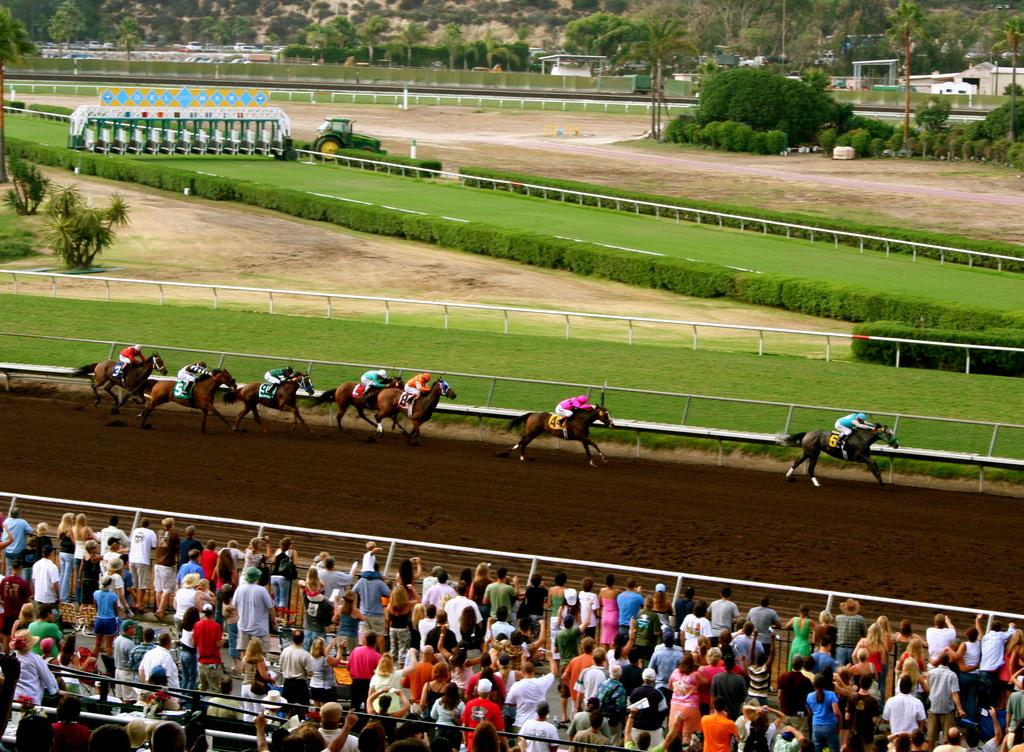What are the people in the image doing? There is a group of people riding horses in the image. What objects can be seen in the image that are made of metal? Iron rods are present in the image. What type of vegetation can be seen in the image? There are plants and trees in the image. What mode of transportation can be seen in the image? There are vehicles in the image. What structures can be seen in the image that are used for support? Poles are present in the image. Are there any other people in the image besides those riding horses? Yes, there is a group of people standing in the image. Can you describe any other items visible in the image? There are some other items in the image, but their specific nature is not mentioned in the provided facts. How many frogs are jumping around the horses in the image? There are no frogs present in the image; it features a group of people riding horses. What type of animal is pulling the carriage in the image? There is no carriage present in the image; it features a group of people riding horses and a group of people standing nearby. 